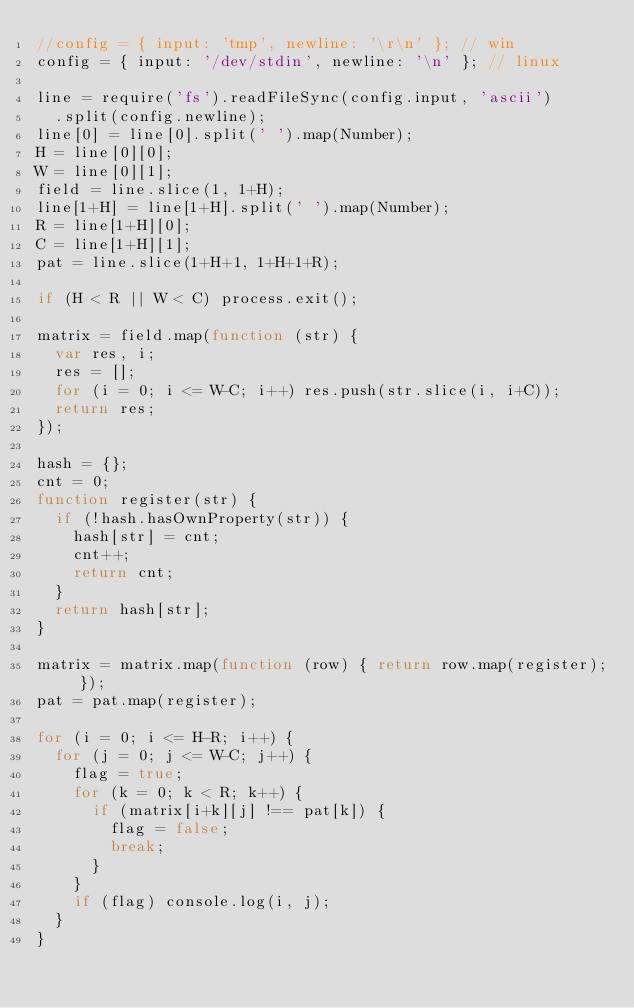Convert code to text. <code><loc_0><loc_0><loc_500><loc_500><_JavaScript_>//config = { input: 'tmp', newline: '\r\n' }; // win
config = { input: '/dev/stdin', newline: '\n' }; // linux

line = require('fs').readFileSync(config.input, 'ascii')
  .split(config.newline);
line[0] = line[0].split(' ').map(Number);
H = line[0][0];
W = line[0][1];
field = line.slice(1, 1+H);
line[1+H] = line[1+H].split(' ').map(Number);
R = line[1+H][0];
C = line[1+H][1];
pat = line.slice(1+H+1, 1+H+1+R);

if (H < R || W < C) process.exit();

matrix = field.map(function (str) {
  var res, i;
  res = [];
  for (i = 0; i <= W-C; i++) res.push(str.slice(i, i+C));
  return res;
});

hash = {};
cnt = 0;
function register(str) {
  if (!hash.hasOwnProperty(str)) {
    hash[str] = cnt;
    cnt++;
    return cnt;
  }
  return hash[str];
}

matrix = matrix.map(function (row) { return row.map(register); });
pat = pat.map(register);

for (i = 0; i <= H-R; i++) {
  for (j = 0; j <= W-C; j++) {
    flag = true;
    for (k = 0; k < R; k++) {
      if (matrix[i+k][j] !== pat[k]) {
        flag = false;
        break;
      }
    }
    if (flag) console.log(i, j);
  }
}</code> 